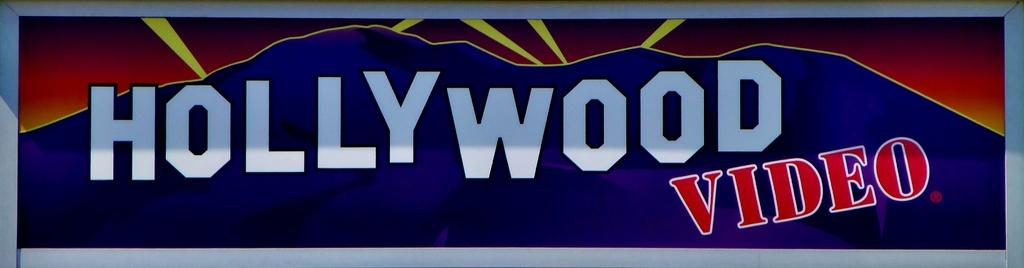<image>
Share a concise interpretation of the image provided. Banner with mountains in the background and words that say "Hollywood Video". 